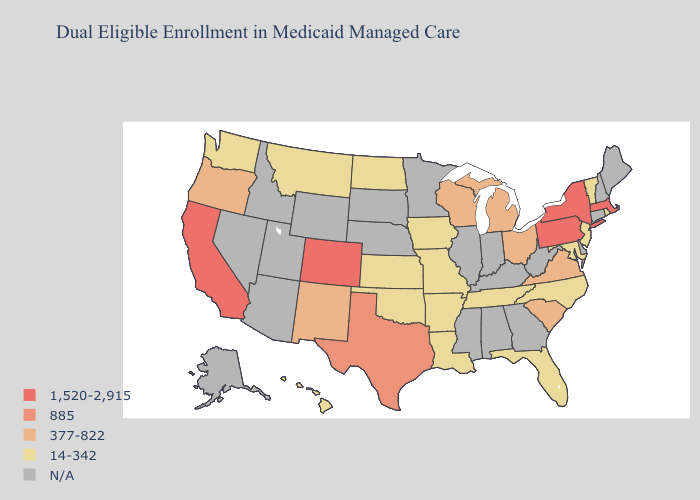What is the highest value in states that border New Mexico?
Be succinct. 1,520-2,915. Which states have the lowest value in the South?
Concise answer only. Arkansas, Florida, Louisiana, Maryland, North Carolina, Oklahoma, Tennessee. Name the states that have a value in the range N/A?
Quick response, please. Alabama, Alaska, Arizona, Connecticut, Delaware, Georgia, Idaho, Illinois, Indiana, Kentucky, Maine, Minnesota, Mississippi, Nebraska, Nevada, New Hampshire, South Dakota, Utah, West Virginia, Wyoming. Does California have the highest value in the West?
Be succinct. Yes. Name the states that have a value in the range N/A?
Write a very short answer. Alabama, Alaska, Arizona, Connecticut, Delaware, Georgia, Idaho, Illinois, Indiana, Kentucky, Maine, Minnesota, Mississippi, Nebraska, Nevada, New Hampshire, South Dakota, Utah, West Virginia, Wyoming. Which states have the highest value in the USA?
Quick response, please. California, Colorado, Massachusetts, New York, Pennsylvania. Name the states that have a value in the range 1,520-2,915?
Write a very short answer. California, Colorado, Massachusetts, New York, Pennsylvania. Among the states that border Delaware , which have the highest value?
Be succinct. Pennsylvania. Does Rhode Island have the lowest value in the USA?
Short answer required. Yes. What is the value of North Carolina?
Be succinct. 14-342. Name the states that have a value in the range 1,520-2,915?
Concise answer only. California, Colorado, Massachusetts, New York, Pennsylvania. What is the value of Delaware?
Quick response, please. N/A. What is the highest value in states that border West Virginia?
Answer briefly. 1,520-2,915. What is the lowest value in the West?
Give a very brief answer. 14-342. Among the states that border Nevada , does Oregon have the lowest value?
Give a very brief answer. Yes. 